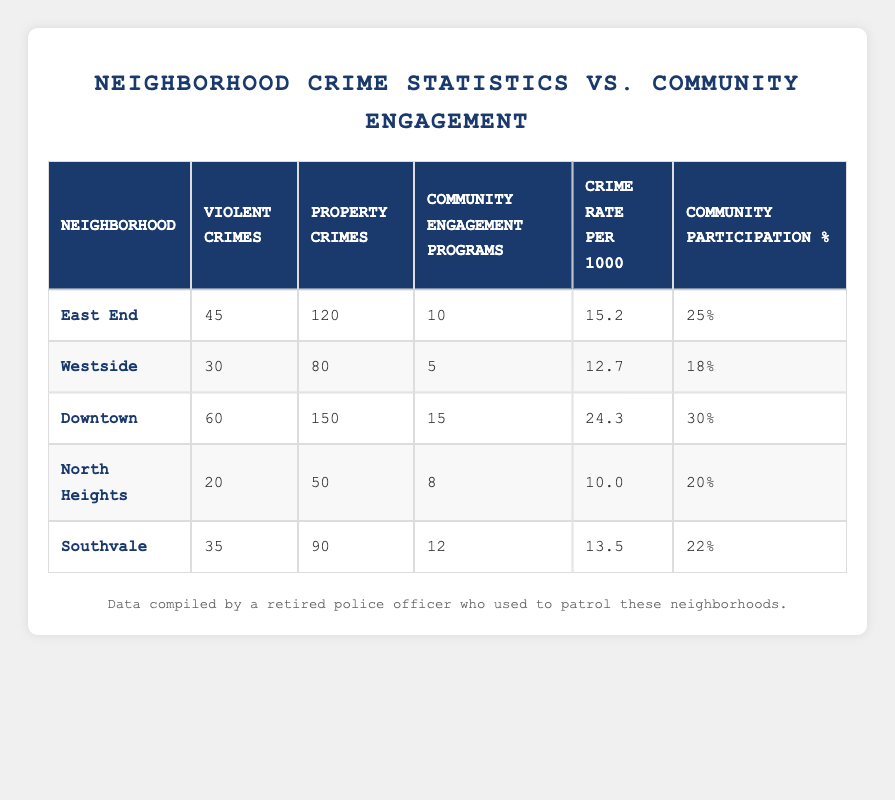What is the neighborhood with the highest number of violent crimes? Looking at the "Violent Crimes" column, Downtown has the highest count with 60 violent crimes reported.
Answer: Downtown What is the total number of community engagement programs across all neighborhoods? Adding up the "Community Engagement Programs" for each neighborhood: 10 + 5 + 15 + 8 + 12 = 50.
Answer: 50 Is the community participation percentage in North Heights higher than in Southvale? North Heights has a participation percentage of 20%, while Southvale has 22%. Since 20% is less than 22%, the statement is false.
Answer: No Which neighborhood has the lowest crime rate per 1000? The "Crime Rate per 1000" for North Heights is 10.0, which is the lowest of all neighborhoods listed.
Answer: North Heights What is the average number of property crimes across the neighborhoods? Adding the property crimes: 120 + 80 + 150 + 50 + 90 = 490. There are 5 neighborhoods, so the average is 490 / 5 = 98.
Answer: 98 In which neighborhood are there more community engagement programs than violent crimes? For North Heights, there are 8 community engagement programs and 20 violent crimes. For Southvale, there are 12 community engagement programs and 35 violent crimes. Both neighborhoods have fewer community engagement programs than violent crimes.
Answer: None What is the neighborhood with the second highest community participation percentage? Looking at the "Community Participation %" column, Downtown has the highest at 30%, and East End is the second highest with 25%.
Answer: East End If the crime rates for Downtown and Westside were combined, what would be their average crime rate per 1000? Adding their crime rates gives 24.3 (Downtown) + 12.7 (Westside) = 37.0. The average is then 37.0 / 2 = 18.5.
Answer: 18.5 Which neighborhoods have a crime rate higher than 15? East End and Downtown have crime rates (15.2 and 24.3 respectively) above 15. Westside, North Heights, and Southvale do not exceed this rate.
Answer: East End, Downtown 